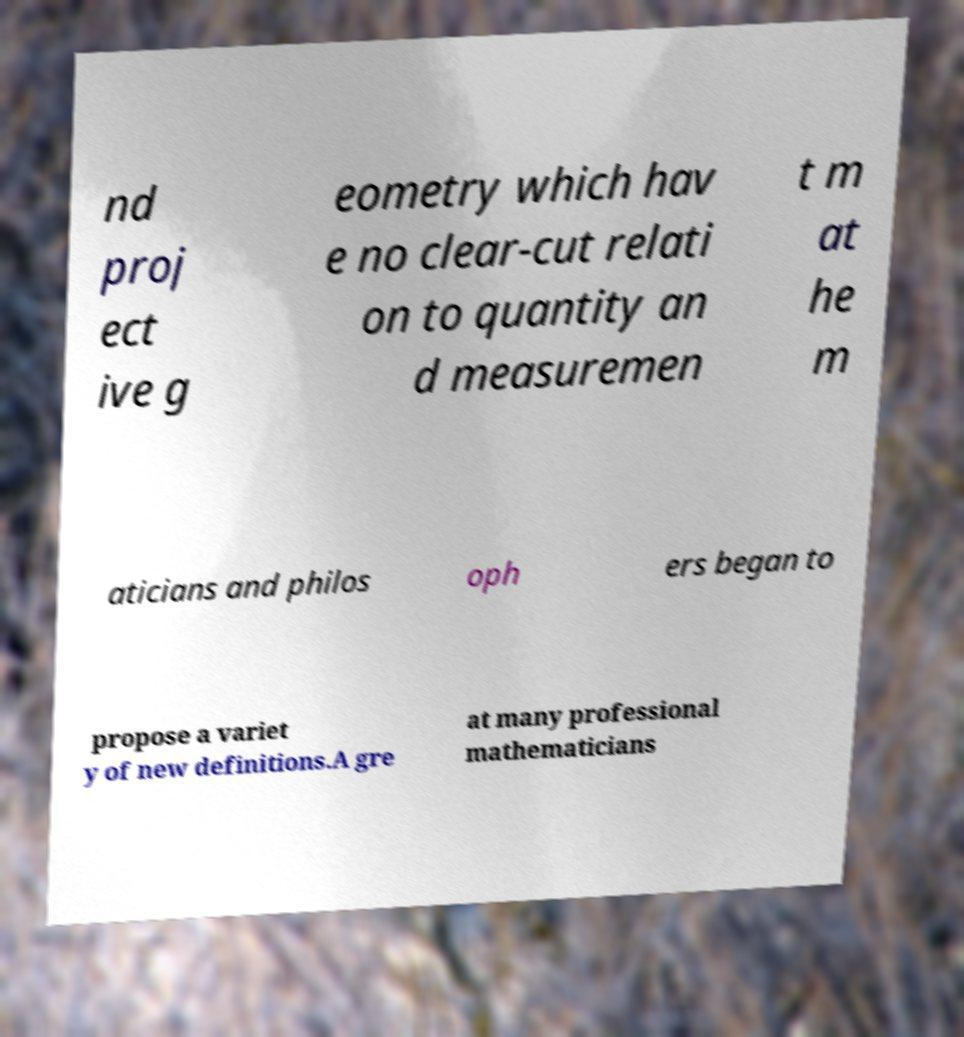Please identify and transcribe the text found in this image. nd proj ect ive g eometry which hav e no clear-cut relati on to quantity an d measuremen t m at he m aticians and philos oph ers began to propose a variet y of new definitions.A gre at many professional mathematicians 